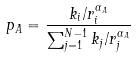<formula> <loc_0><loc_0><loc_500><loc_500>p _ { A } = \frac { k _ { i } / r ^ { \alpha _ { A } } _ { i } } { \sum _ { j = 1 } ^ { N - 1 } k _ { j } / r ^ { \alpha _ { A } } _ { j } }</formula> 